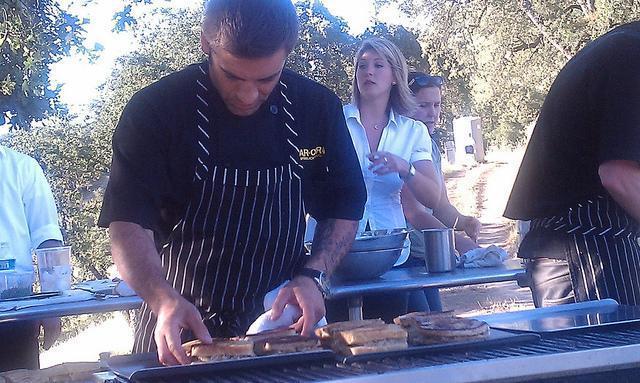How many sandwiches are there?
Give a very brief answer. 2. How many people can you see?
Give a very brief answer. 5. 